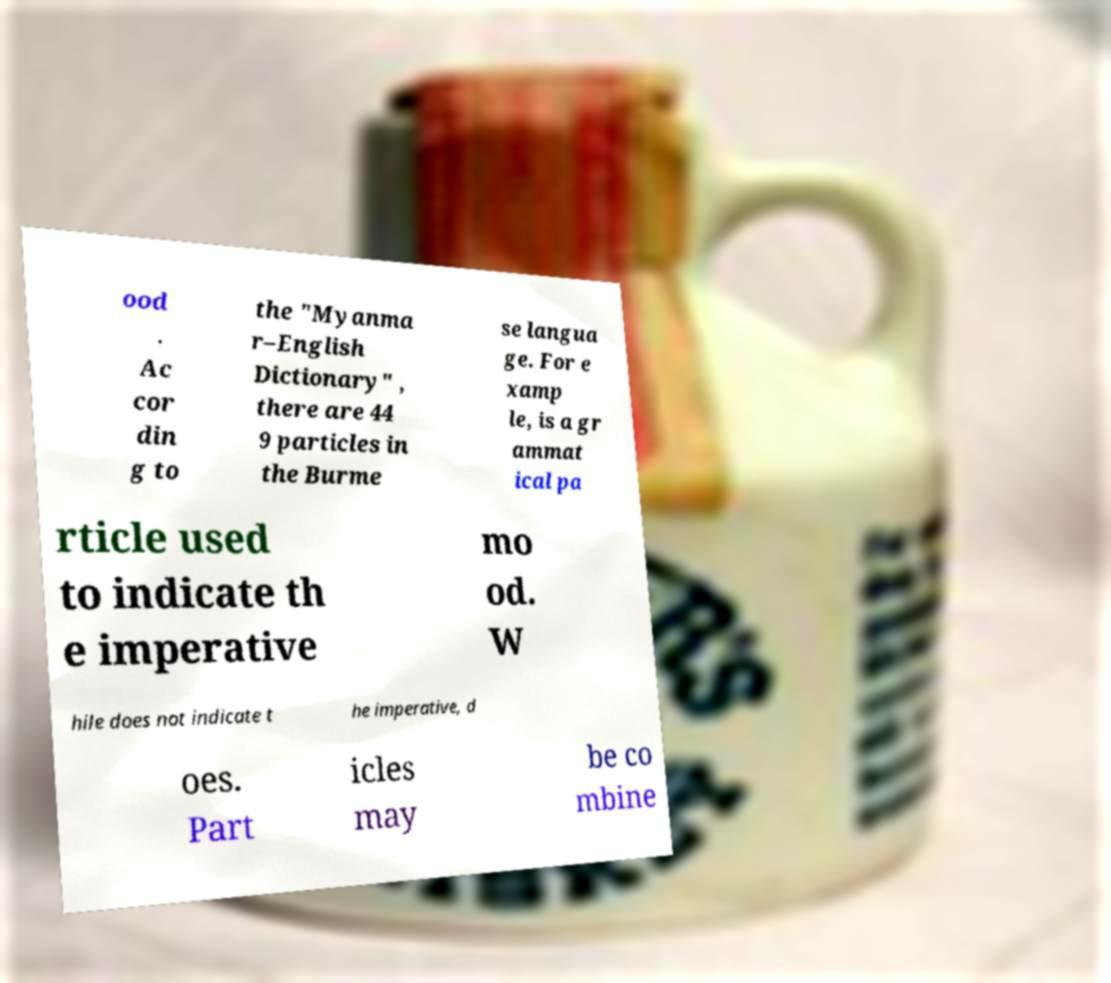Could you extract and type out the text from this image? ood . Ac cor din g to the "Myanma r–English Dictionary" , there are 44 9 particles in the Burme se langua ge. For e xamp le, is a gr ammat ical pa rticle used to indicate th e imperative mo od. W hile does not indicate t he imperative, d oes. Part icles may be co mbine 